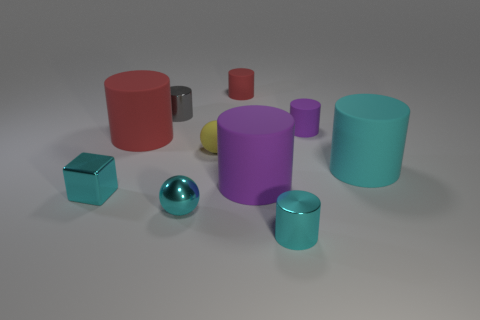Subtract all cyan matte cylinders. How many cylinders are left? 6 Subtract all gray spheres. How many cyan cylinders are left? 2 Subtract all cyan spheres. How many spheres are left? 1 Subtract all spheres. How many objects are left? 8 Subtract all large purple cylinders. Subtract all tiny cyan metallic things. How many objects are left? 6 Add 8 large purple objects. How many large purple objects are left? 9 Add 4 tiny cyan metal cubes. How many tiny cyan metal cubes exist? 5 Subtract 0 gray balls. How many objects are left? 10 Subtract all gray balls. Subtract all cyan cylinders. How many balls are left? 2 